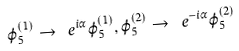Convert formula to latex. <formula><loc_0><loc_0><loc_500><loc_500>\varphi _ { 5 } ^ { ( 1 ) } \to \ e ^ { i \alpha } \varphi _ { 5 } ^ { ( 1 ) } , \varphi _ { 5 } ^ { ( 2 ) } \to \ e ^ { - i \alpha } \varphi _ { 5 } ^ { ( 2 ) }</formula> 